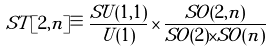Convert formula to latex. <formula><loc_0><loc_0><loc_500><loc_500>S T [ 2 , n ] \equiv \frac { S U ( 1 , 1 ) } { U ( 1 ) } \times \frac { S O ( 2 , n ) } { S O ( 2 ) \times S O ( n ) }</formula> 